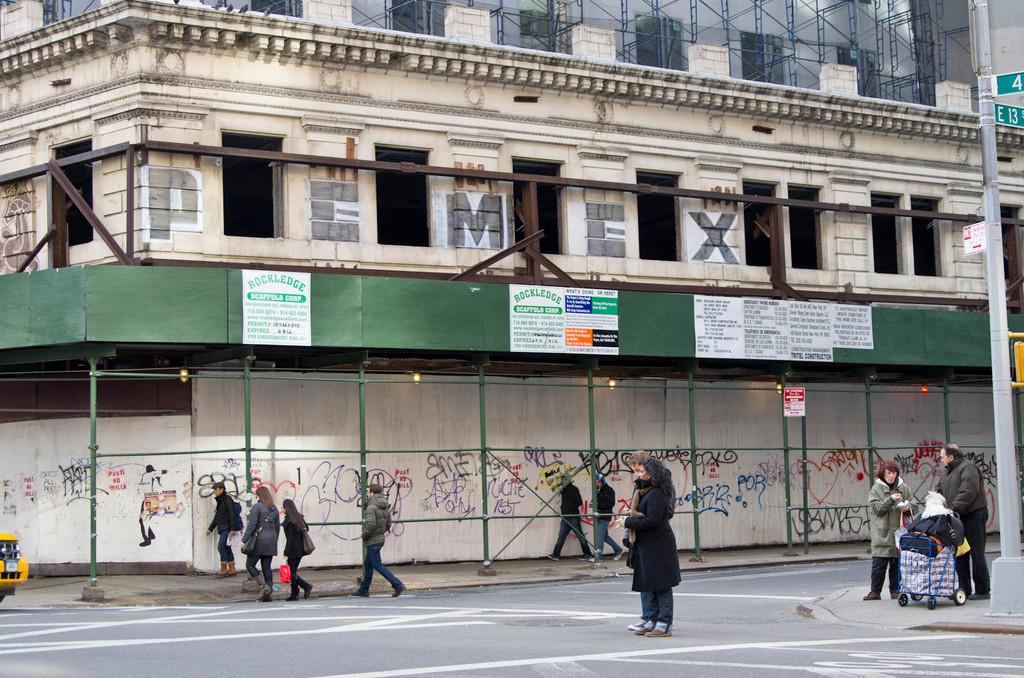What are the black letters on the building?
Offer a very short reply. Pemex. What odes the sign on the left say?
Offer a terse response. Rockledge. 